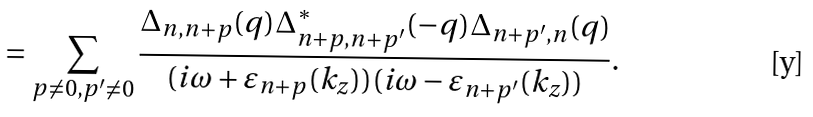<formula> <loc_0><loc_0><loc_500><loc_500>= \sum _ { p \not = 0 , p ^ { \prime } \not = 0 } \frac { \Delta _ { n , n + p } ( { q } ) \Delta ^ { * } _ { n + p , n + p ^ { \prime } } ( - { q } ) \Delta _ { n + p ^ { \prime } , n } ( { q } ) } { ( i \omega + \varepsilon _ { n + p } ( k _ { z } ) ) ( i \omega - \varepsilon _ { n + p ^ { \prime } } ( k _ { z } ) ) } .</formula> 